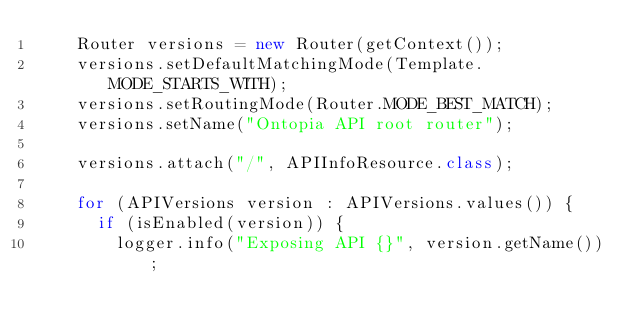Convert code to text. <code><loc_0><loc_0><loc_500><loc_500><_Java_>		Router versions = new Router(getContext());
		versions.setDefaultMatchingMode(Template.MODE_STARTS_WITH);
		versions.setRoutingMode(Router.MODE_BEST_MATCH);
		versions.setName("Ontopia API root router");
		
		versions.attach("/", APIInfoResource.class);
		
		for (APIVersions version : APIVersions.values()) {
			if (isEnabled(version)) {
				logger.info("Exposing API {}", version.getName());</code> 